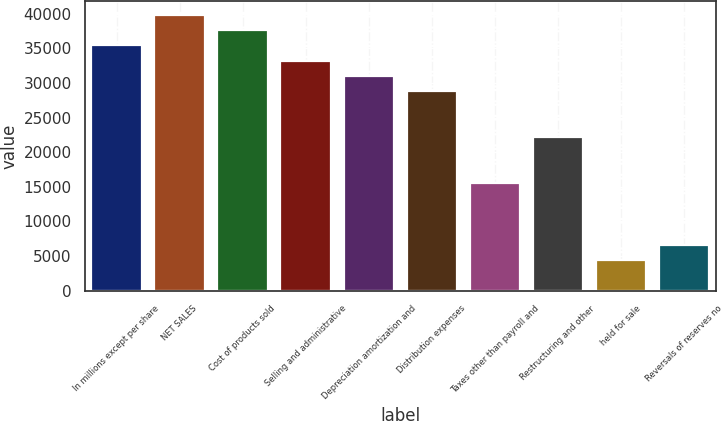Convert chart to OTSL. <chart><loc_0><loc_0><loc_500><loc_500><bar_chart><fcel>In millions except per share<fcel>NET SALES<fcel>Cost of products sold<fcel>Selling and administrative<fcel>Depreciation amortization and<fcel>Distribution expenses<fcel>Taxes other than payroll and<fcel>Restructuring and other<fcel>held for sale<fcel>Reversals of reserves no<nl><fcel>35420.5<fcel>39848<fcel>37634.3<fcel>33206.8<fcel>30993<fcel>28779.3<fcel>15496.8<fcel>22138<fcel>4428.04<fcel>6641.79<nl></chart> 